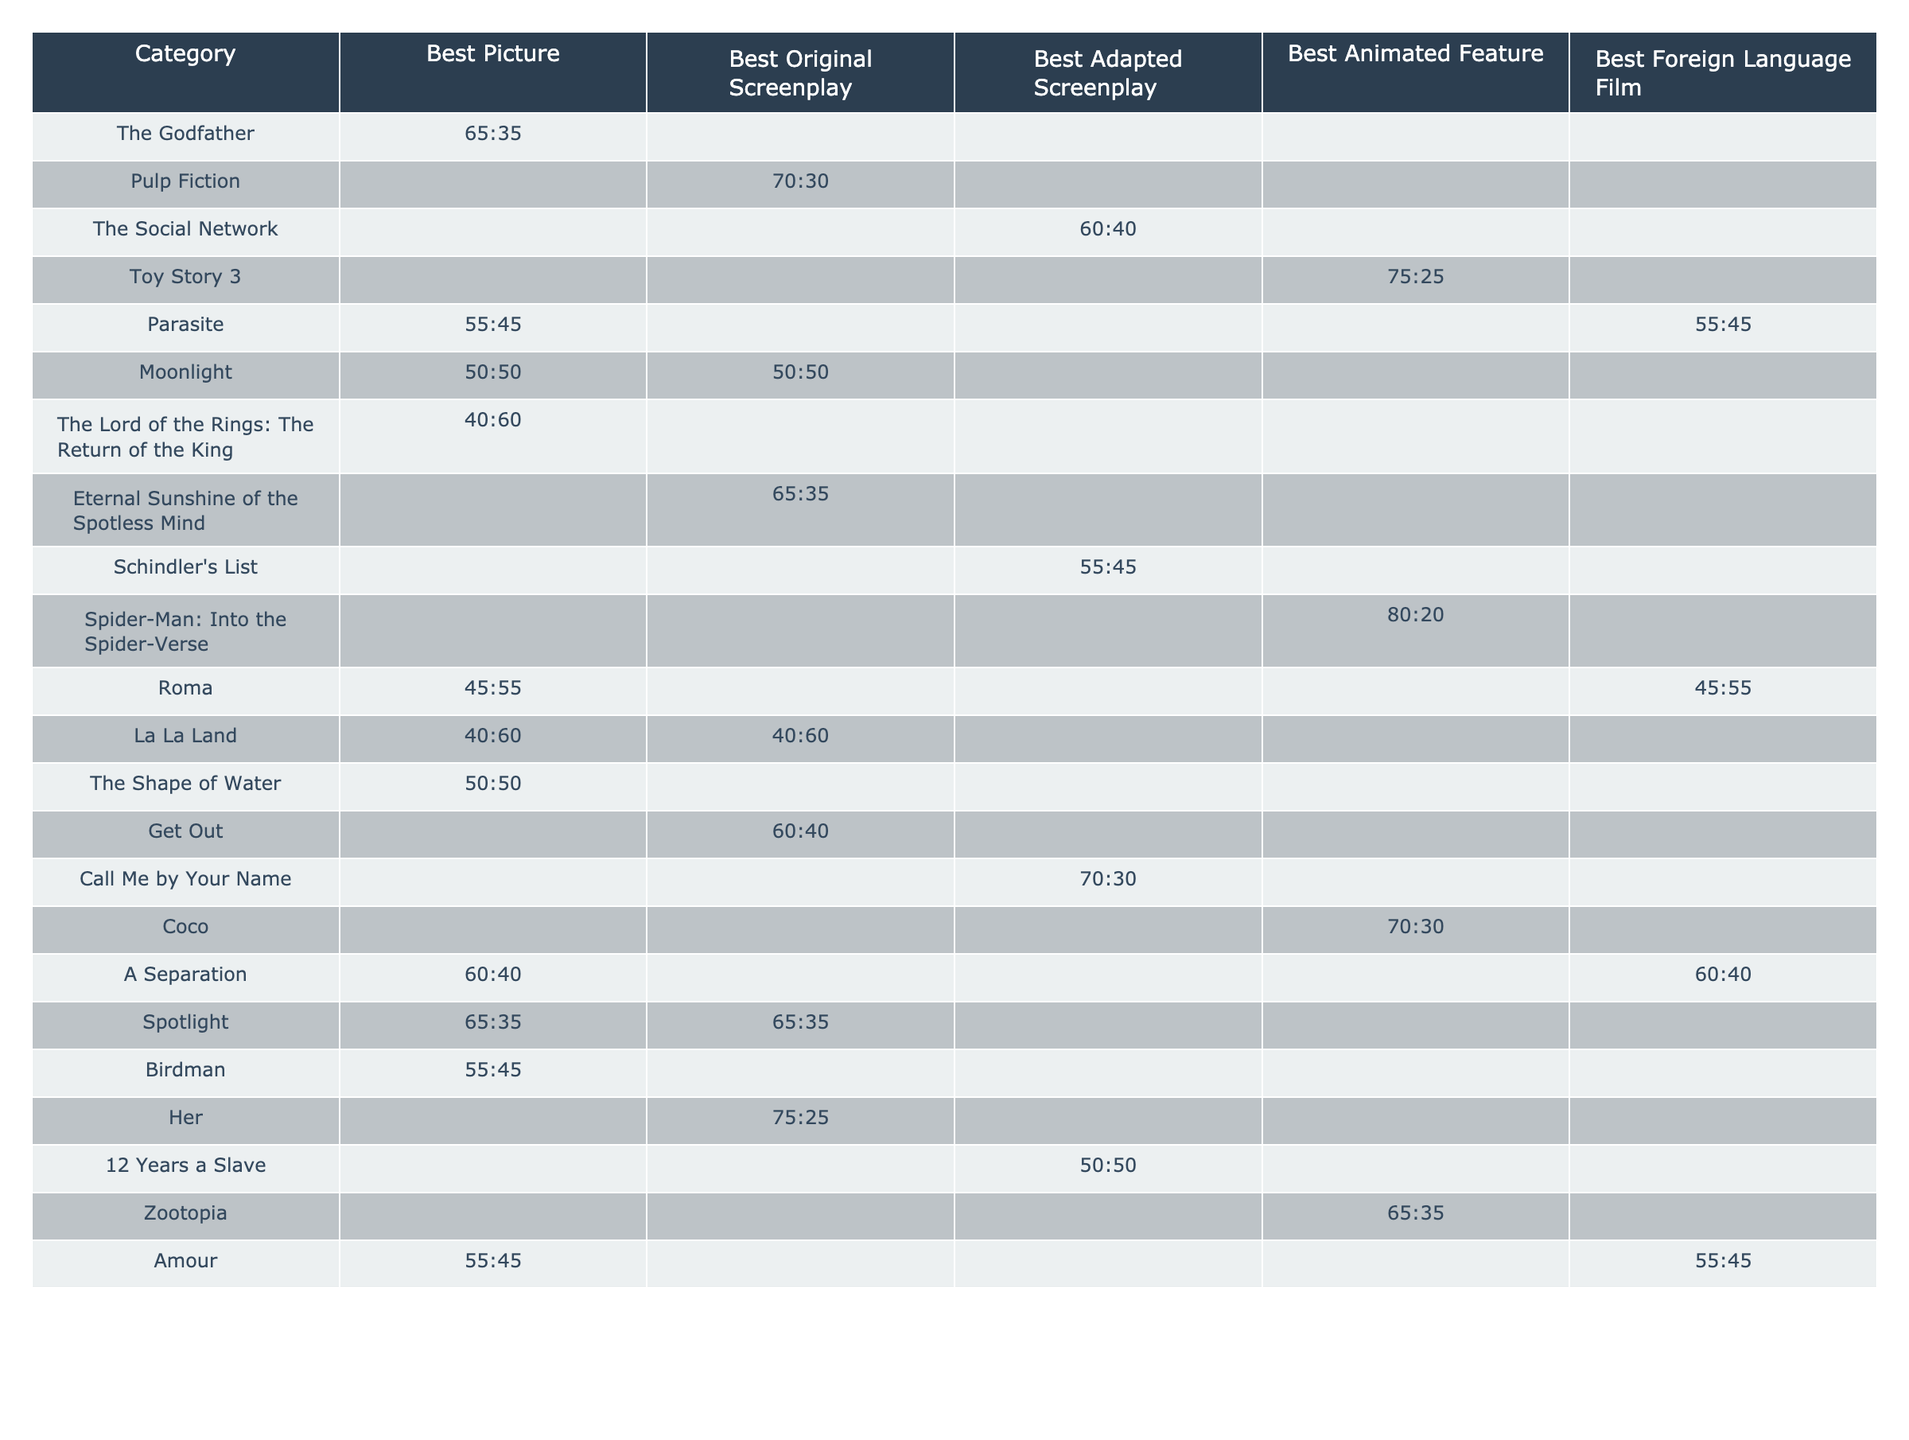What is the dialogue-to-action ratio of "The Godfather"? The table shows the dialogue-to-action ratio for "The Godfather" as 65:35, meaning 65% dialogue and 35% action.
Answer: 65:35 Which script has the highest action percentage? By looking at the table, "Spider-Man: Into the Spider-Verse" has an action percentage of 80%, as indicated by the ratio of 80:20.
Answer: 80% Is there a script that has the same ratio for both Best Picture and Best Original Screenplay? "Moonlight" has a ratio of 50:50 for both Best Picture and Best Original Screenplay, as shown in the table.
Answer: Yes What is the average dialogue-to-action ratio for Best Adapted Screenplay scripts? The scripts with ratios for Best Adapted Screenplay are "The Social Network" (60:40), "Schindler's List" (55:45), "12 Years a Slave" (50:50), and "Call Me by Your Name" (70:30). The average is calculated as follows: (60 + 55 + 50 + 70)/(4) = 58.75 for dialogue and (40 + 45 + 50 + 30)/(4) = 41.25 for action, resulting in an average ratio of 58.75:41.25.
Answer: 58.75:41.25 Which categories does "Parasite" appear under, and what are its dialogue-to-action ratios? "Parasite" appears in both Best Picture and Best Foreign Language Film categories, with a dialogue-to-action ratio of 55:45 for Best Picture and 55:45 for Best Foreign Language Film.
Answer: Best Picture and Best Foreign Language Film; 55:45, 55:45 Do any scripts have a dialogue-to-action ratio of 40:60? Looking at the table, "The Lord of the Rings: The Return of the King" and "La La Land" both have a ratio of 40:60, indicating 40% dialogue and 60% action.
Answer: Yes What percentage of scripts under Best Animated Feature category have a higher dialogue percentage than action? In the Best Animated Feature category, there are three scripts: "Toy Story 3" (75:25), "Spider-Man: Into the Spider-Verse" (80:20), and "Zootopia" (65:35). All these scripts have a higher dialogue percentage than action, leading to a total of three out of three scripts.
Answer: 100% What is the maximum action percentage among the Best Original Screenplay category? The only script listed under Best Original Screenplay with an action percentage is "Pulp Fiction," with a ratio of 30% action (70:30). As it is the sole entry, it represents the maximum percentage.
Answer: 30% 